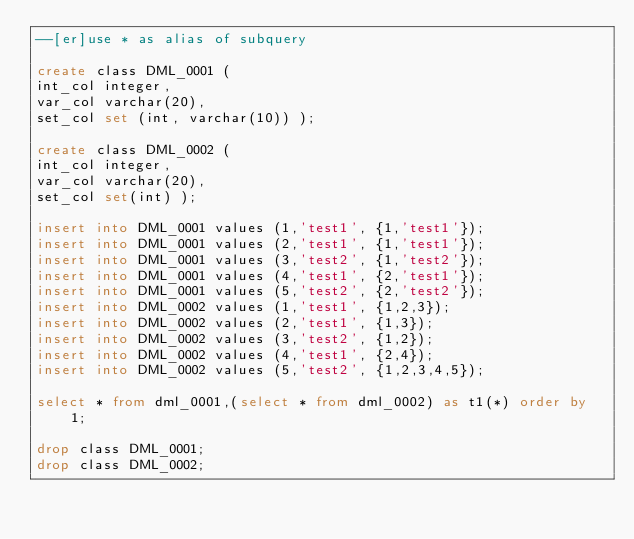Convert code to text. <code><loc_0><loc_0><loc_500><loc_500><_SQL_>--[er]use * as alias of subquery

create class DML_0001 ( 
int_col integer,
var_col varchar(20),
set_col set (int, varchar(10)) );

create class DML_0002 ( 
int_col integer,
var_col varchar(20),
set_col set(int) );

insert into DML_0001 values (1,'test1', {1,'test1'});
insert into DML_0001 values (2,'test1', {1,'test1'});
insert into DML_0001 values (3,'test2', {1,'test2'});
insert into DML_0001 values (4,'test1', {2,'test1'});
insert into DML_0001 values (5,'test2', {2,'test2'});
insert into DML_0002 values (1,'test1', {1,2,3});
insert into DML_0002 values (2,'test1', {1,3});
insert into DML_0002 values (3,'test2', {1,2});
insert into DML_0002 values (4,'test1', {2,4});
insert into DML_0002 values (5,'test2', {1,2,3,4,5});

select * from dml_0001,(select * from dml_0002) as t1(*) order by 1;

drop class DML_0001;
drop class DML_0002;
</code> 